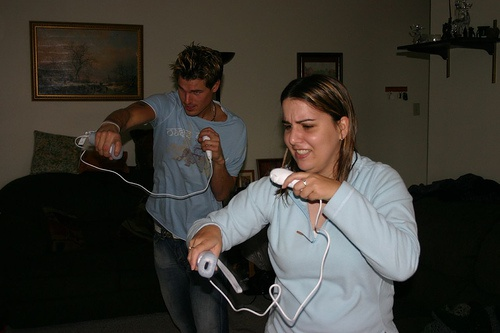Describe the objects in this image and their specific colors. I can see people in black, darkgray, and brown tones, couch in black and gray tones, people in black, gray, maroon, and purple tones, couch in black and gray tones, and remote in black, darkgray, gray, and lightgray tones in this image. 